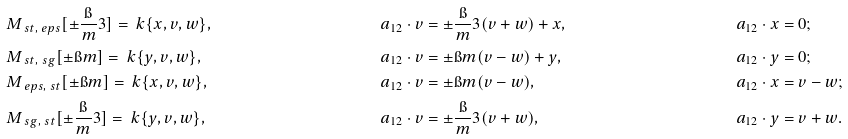Convert formula to latex. <formula><loc_0><loc_0><loc_500><loc_500>& M _ { \ s t , \ e p s } [ \pm \frac { \i } { m } 3 ] = \ k \{ x , v , w \} , & & a _ { 1 2 } \cdot v = \pm \frac { \i } { m } 3 ( v + w ) + x , & & a _ { 1 2 } \cdot x = 0 ; \\ & M _ { \ s t , \ s g } [ \pm \i m ] = \ k \{ y , v , w \} , & & a _ { 1 2 } \cdot v = \pm \i m ( v - w ) + y , & & a _ { 1 2 } \cdot y = 0 ; \\ & M _ { \ e p s , \ s t } [ \pm \i m ] = \ k \{ x , v , w \} , & & a _ { 1 2 } \cdot v = \pm \i m ( v - w ) , & & a _ { 1 2 } \cdot x = v - w ; \\ & M _ { \ s g , \ s t } [ \pm \frac { \i } { m } 3 ] = \ k \{ y , v , w \} , & & a _ { 1 2 } \cdot v = \pm \frac { \i } { m } 3 ( v + w ) , & & a _ { 1 2 } \cdot y = v + w .</formula> 